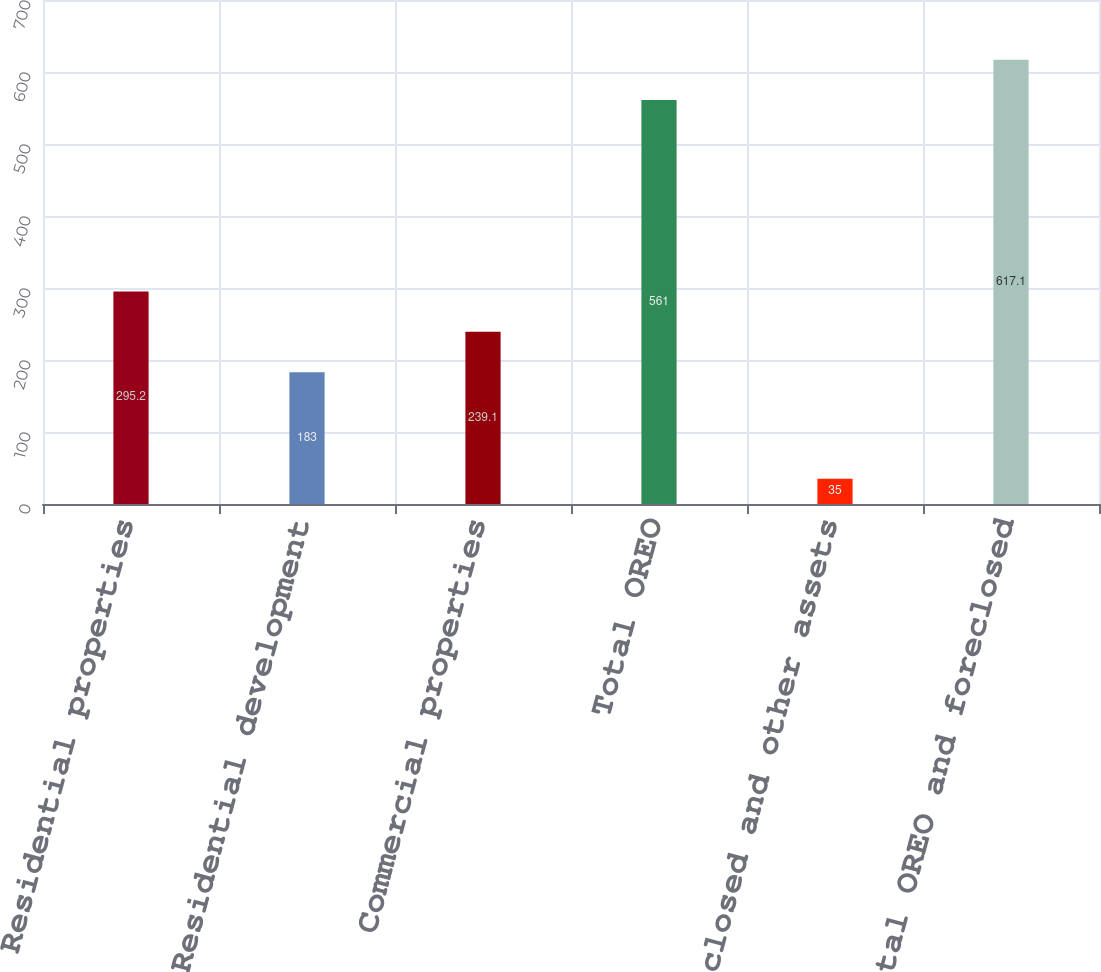Convert chart to OTSL. <chart><loc_0><loc_0><loc_500><loc_500><bar_chart><fcel>Residential properties<fcel>Residential development<fcel>Commercial properties<fcel>Total OREO<fcel>Foreclosed and other assets<fcel>Total OREO and foreclosed<nl><fcel>295.2<fcel>183<fcel>239.1<fcel>561<fcel>35<fcel>617.1<nl></chart> 